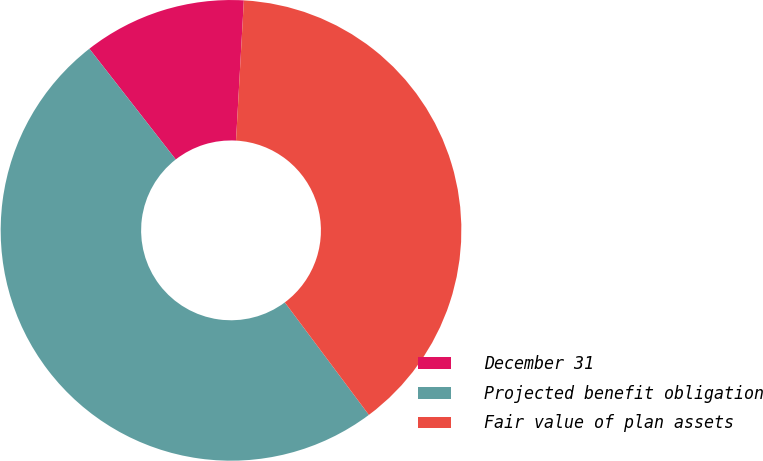<chart> <loc_0><loc_0><loc_500><loc_500><pie_chart><fcel>December 31<fcel>Projected benefit obligation<fcel>Fair value of plan assets<nl><fcel>11.43%<fcel>49.67%<fcel>38.9%<nl></chart> 